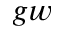<formula> <loc_0><loc_0><loc_500><loc_500>g w</formula> 